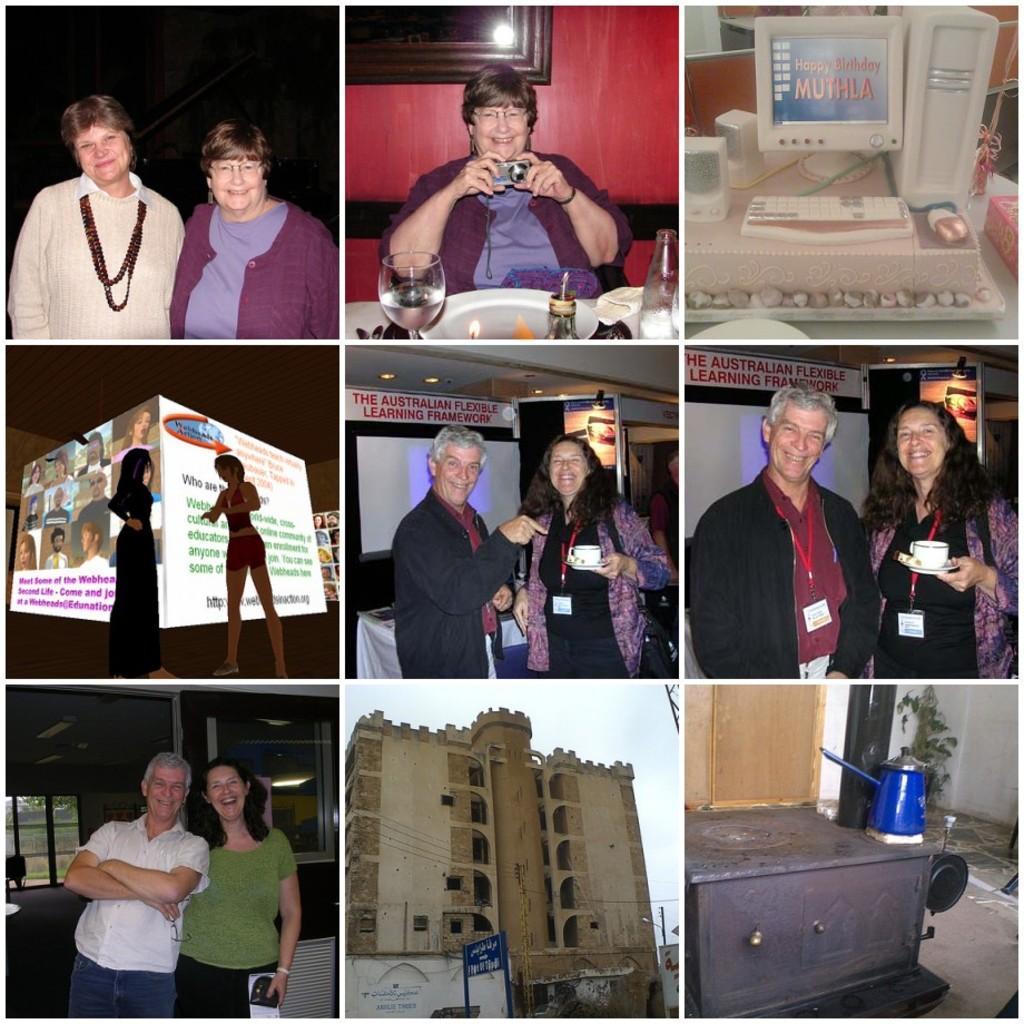Describe this image in one or two sentences. In the picture I can see nine images. In the First row first image we can see two person standing and smiling. In the first row second image we can see a person holding camera is sitting and smiling, we can see glass, candle and bottles are placed. In the First row third image we can see computer, CPU, keyboards, speakers and mouse. In the second row first picture we can see an animated picture in which we can see two persons are standing and we can see boards. In the second row second picture we can see two persons are standing and smiling. In the second row third picture we can see two persons standing and smiling. In the background, we can see some objects. In the third row first picture we can see two persons are standing. In the third row second picture we can see a building and board. In the third row third image we can see some objects, plant and door. 